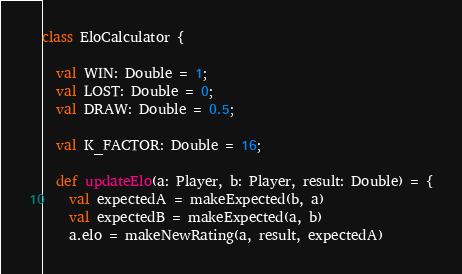<code> <loc_0><loc_0><loc_500><loc_500><_Scala_>class EloCalculator {

  val WIN: Double = 1;
  val LOST: Double = 0;
  val DRAW: Double = 0.5;

  val K_FACTOR: Double = 16;

  def updateElo(a: Player, b: Player, result: Double) = {
    val expectedA = makeExpected(b, a)
    val expectedB = makeExpected(a, b)
    a.elo = makeNewRating(a, result, expectedA)</code> 